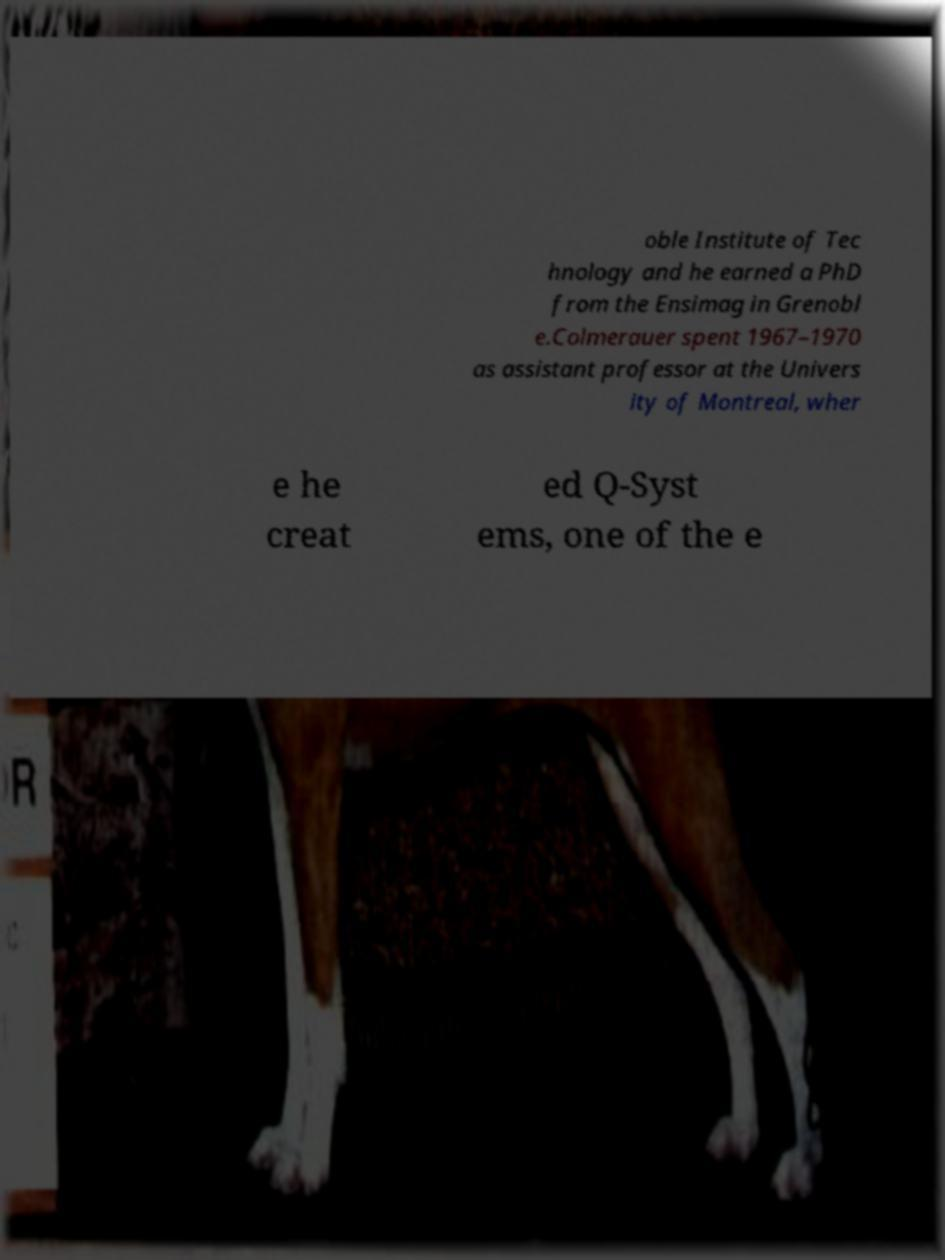For documentation purposes, I need the text within this image transcribed. Could you provide that? oble Institute of Tec hnology and he earned a PhD from the Ensimag in Grenobl e.Colmerauer spent 1967–1970 as assistant professor at the Univers ity of Montreal, wher e he creat ed Q-Syst ems, one of the e 